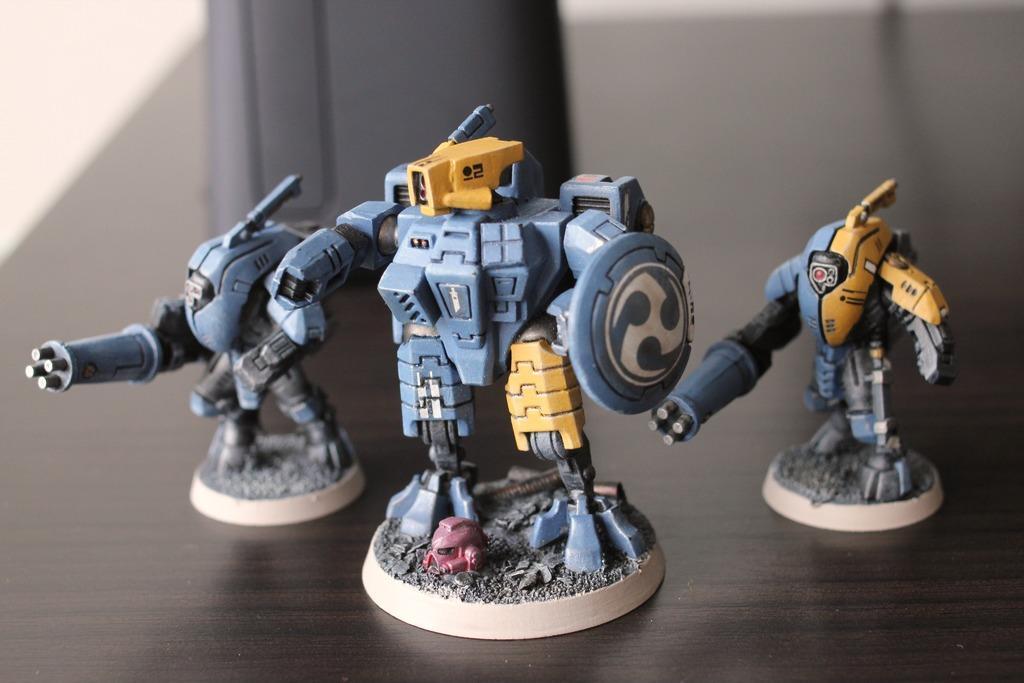Describe this image in one or two sentences. In this image, there are toys and an object on a platform. There is a blurred background. 